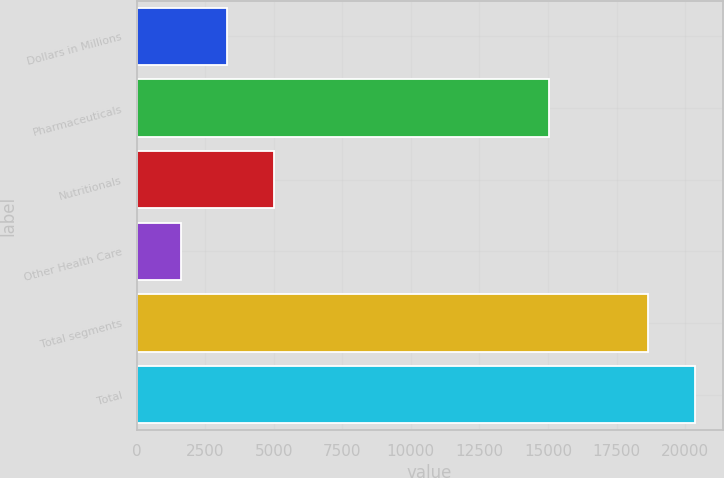<chart> <loc_0><loc_0><loc_500><loc_500><bar_chart><fcel>Dollars in Millions<fcel>Pharmaceuticals<fcel>Nutritionals<fcel>Other Health Care<fcel>Total segments<fcel>Total<nl><fcel>3309.8<fcel>15025<fcel>5014.6<fcel>1605<fcel>18653<fcel>20357.8<nl></chart> 